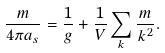Convert formula to latex. <formula><loc_0><loc_0><loc_500><loc_500>\frac { m } { 4 \pi a _ { s } } = \frac { 1 } { g } + \frac { 1 } { V } \sum _ { k } \frac { m } { k ^ { 2 } } .</formula> 